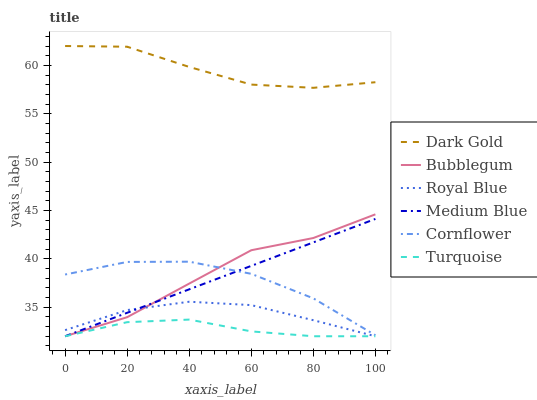Does Turquoise have the minimum area under the curve?
Answer yes or no. Yes. Does Dark Gold have the maximum area under the curve?
Answer yes or no. Yes. Does Dark Gold have the minimum area under the curve?
Answer yes or no. No. Does Turquoise have the maximum area under the curve?
Answer yes or no. No. Is Medium Blue the smoothest?
Answer yes or no. Yes. Is Cornflower the roughest?
Answer yes or no. Yes. Is Turquoise the smoothest?
Answer yes or no. No. Is Turquoise the roughest?
Answer yes or no. No. Does Turquoise have the lowest value?
Answer yes or no. Yes. Does Dark Gold have the lowest value?
Answer yes or no. No. Does Dark Gold have the highest value?
Answer yes or no. Yes. Does Turquoise have the highest value?
Answer yes or no. No. Is Royal Blue less than Dark Gold?
Answer yes or no. Yes. Is Dark Gold greater than Royal Blue?
Answer yes or no. Yes. Does Royal Blue intersect Bubblegum?
Answer yes or no. Yes. Is Royal Blue less than Bubblegum?
Answer yes or no. No. Is Royal Blue greater than Bubblegum?
Answer yes or no. No. Does Royal Blue intersect Dark Gold?
Answer yes or no. No. 